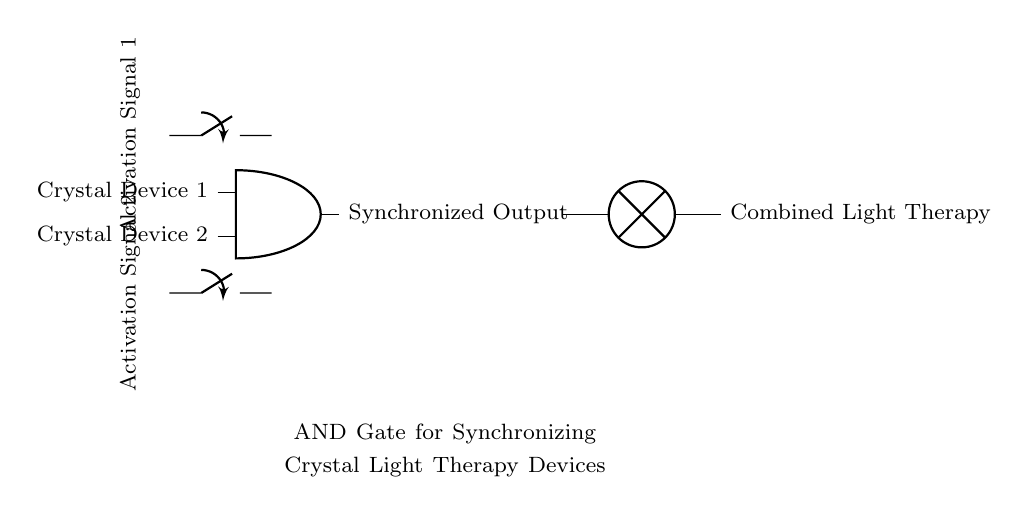What type of logic gate is shown in the circuit? The circuit features an AND gate, which is indicated by the specific symbol used for the logic gate in the diagram.
Answer: AND gate How many activation signals are included in this circuit? The circuit includes two activation signals, as seen on the left side of the diagram labeled "Activation Signal 1" and "Activation Signal 2."
Answer: Two What is the output device connected to the AND gate? The output device connected to the AND gate is a lamp, which is denoted on the right side of the diagram.
Answer: Lamp What is the purpose of this AND gate circuit in terms of the crystal devices? The purpose of the AND gate circuit is to synchronize the crystal light therapy devices by requiring both activation signals to be present for an output.
Answer: Synchronization If both activation signals are off, what would the output be? If both activation signals are off, the output will be off as well, because an AND gate requires both inputs to be active (high) for an active output.
Answer: Off 